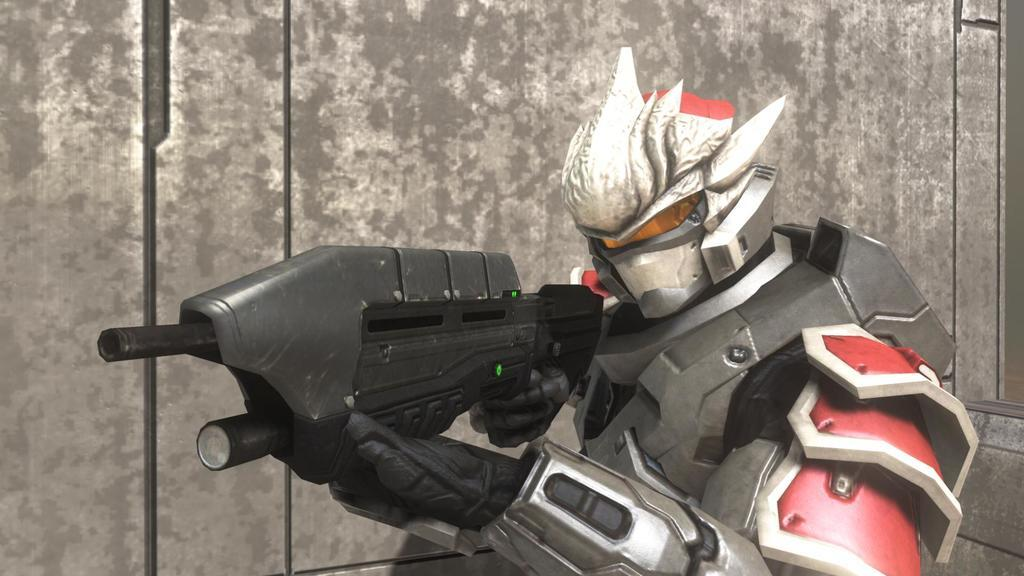What type of character is in the picture? There is an animated character in the picture. What is the animated character holding in their hands? The animated character is holding a gun in their hands. What can be seen in the background of the picture? There is a wall in the background of the picture. What type of learning is the animated character engaged in while holding the gun? There is no indication in the animated character is engaged in any learning activity in the image. The character is simply holding a gun. 